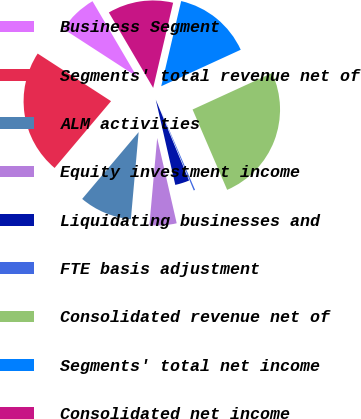Convert chart. <chart><loc_0><loc_0><loc_500><loc_500><pie_chart><fcel>Business Segment<fcel>Segments' total revenue net of<fcel>ALM activities<fcel>Equity investment income<fcel>Liquidating businesses and<fcel>FTE basis adjustment<fcel>Consolidated revenue net of<fcel>Segments' total net income<fcel>Consolidated net income<nl><fcel>7.38%<fcel>22.99%<fcel>9.75%<fcel>5.0%<fcel>2.63%<fcel>0.26%<fcel>25.37%<fcel>14.49%<fcel>12.12%<nl></chart> 